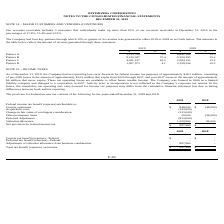According to Optimizerx Corporation's financial document, How much was the net operating loss carry-forwards for federal income tax purposes as of December 31, 2019? approximately $18.3 million. The document states: "carry-forwards for federal income tax purposes of approximately $18.3 million, consisting of pre-2018 losses in the amount of approximately $14.3 mill..." Also, When was the Company formed? According to the financial document, 2006. The relevant text states: "future taxable income. The Company was formed in 2006 as a limited liability company and changed to a corporation in 2007. Activity prior to incorporatio..." Also, How much was the net provision for federal income tax in 2019?  According to the financial document, $897,960. The relevant text states: "Net provision for federal income tax $ 897,960 $ -..." Also, can you calculate: What is the percentage change in valuation allowance in 2019 compared to 2018? To answer this question, I need to perform calculations using the financial data. The calculation is: (1,209,960 - 84,000)/84,000 , which equals 1340.43 (percentage). This is based on the information: "Valuation allowance 1,209,960 84,000 Valuation allowance 1,209,960 84,000..." The key data points involved are: 1,209,960, 84,000. Also, can you calculate: What is the ratio of total federal income tax benefit to total expenses in 2019? To answer this question, I need to perform calculations using the financial data. The calculation is: (848,000+29,000+1,209,960)/(143,000+133,000+913,000) , which equals 1.76. This is based on the information: "Other permanent items 29,000 (36,000) Change in fair value of contingent consideration (133,000) - Deferred Adjustment (913,000) - Acquisition costs (143,000) - Valuation allowance 1,209,960 84,000 Cu..." The key data points involved are: 1,209,960, 133,000, 143,000. Also, can you calculate: What is the average of current operations from 2018 to 2019? To answer this question, I need to perform calculations using the financial data. The calculation is: (848,000+(-48,000))/2 , which equals 400000. This is based on the information: "Current operations $ 848,000 $ (48,000) han 10% of our accounts receivable at December 31, 2019 in the percentages of 17.8%, 15.4% and 13.3%. The Company had four key partners through which 10 Current..." The key data points involved are: 2, 48,000, 848,000. 